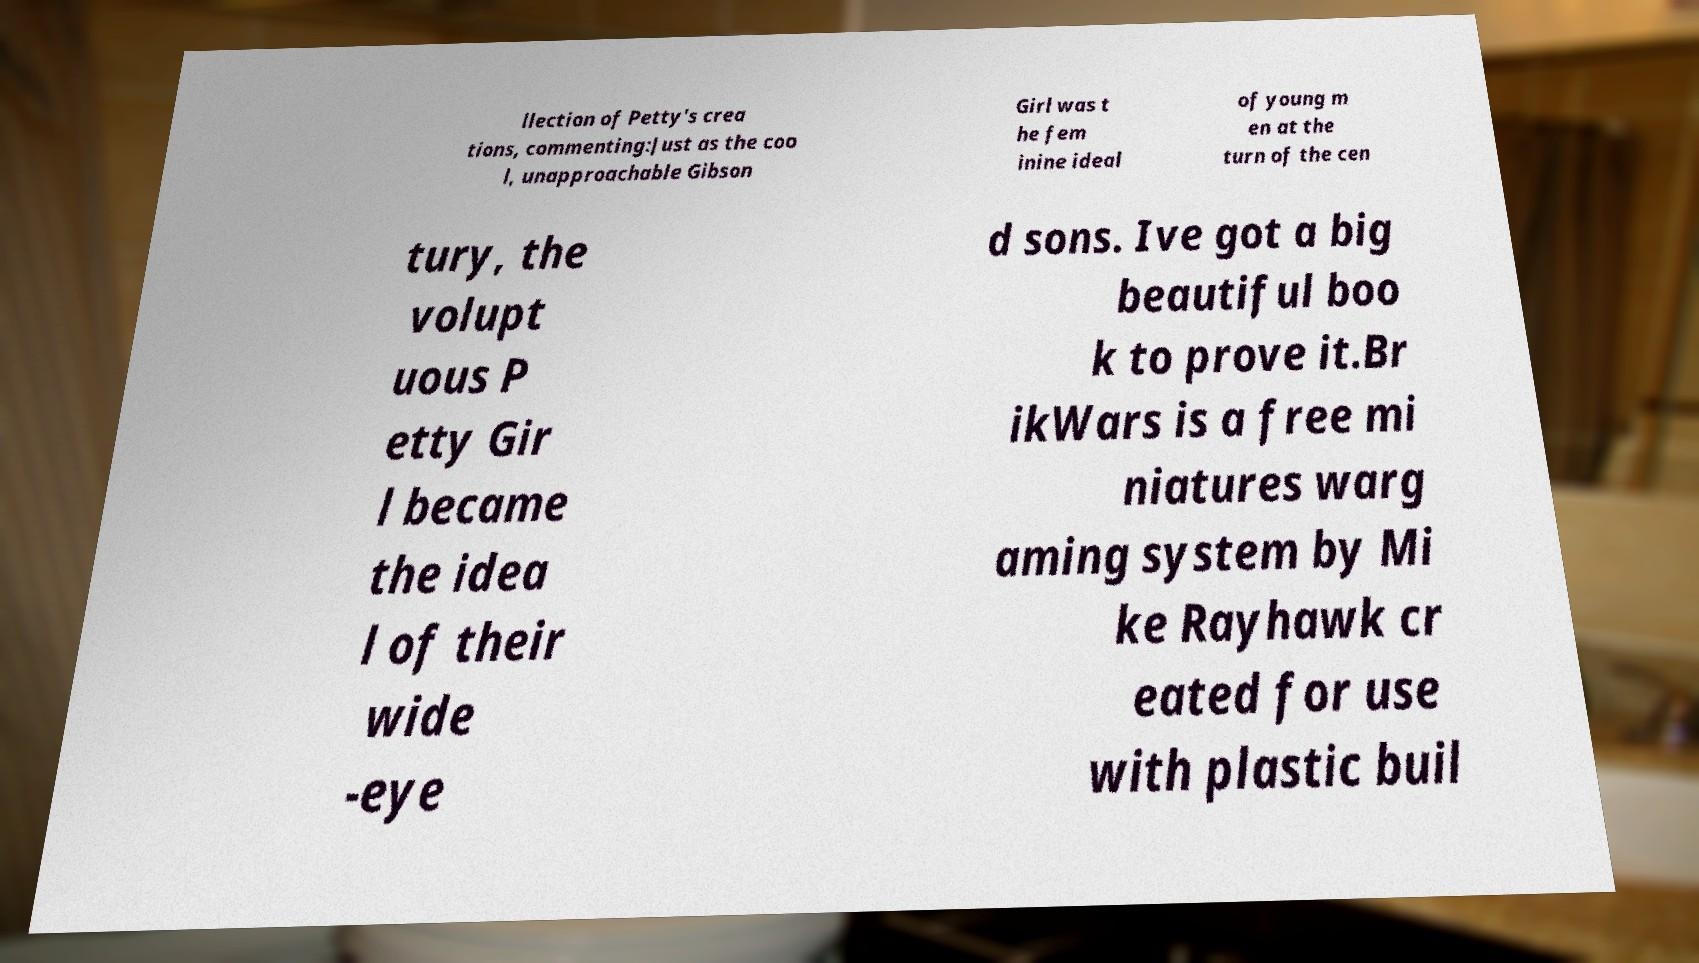Please identify and transcribe the text found in this image. llection of Petty's crea tions, commenting:Just as the coo l, unapproachable Gibson Girl was t he fem inine ideal of young m en at the turn of the cen tury, the volupt uous P etty Gir l became the idea l of their wide -eye d sons. Ive got a big beautiful boo k to prove it.Br ikWars is a free mi niatures warg aming system by Mi ke Rayhawk cr eated for use with plastic buil 